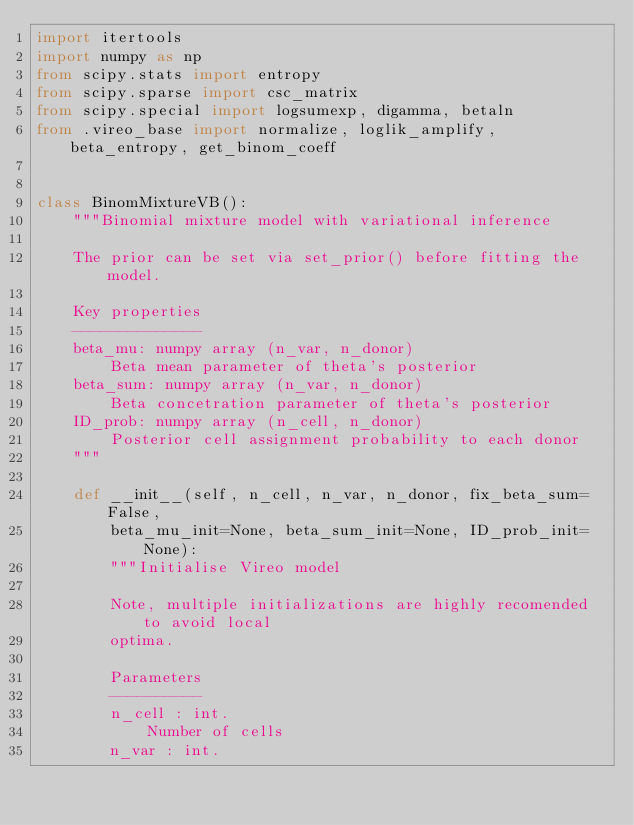Convert code to text. <code><loc_0><loc_0><loc_500><loc_500><_Python_>import itertools
import numpy as np
from scipy.stats import entropy
from scipy.sparse import csc_matrix
from scipy.special import logsumexp, digamma, betaln
from .vireo_base import normalize, loglik_amplify, beta_entropy, get_binom_coeff


class BinomMixtureVB():
    """Binomial mixture model with variational inference

    The prior can be set via set_prior() before fitting the model.

    Key properties
    --------------
    beta_mu: numpy array (n_var, n_donor)
        Beta mean parameter of theta's posterior
    beta_sum: numpy array (n_var, n_donor)
        Beta concetration parameter of theta's posterior
    ID_prob: numpy array (n_cell, n_donor)
        Posterior cell assignment probability to each donor
    """

    def __init__(self, n_cell, n_var, n_donor, fix_beta_sum=False, 
        beta_mu_init=None, beta_sum_init=None, ID_prob_init=None):
        """Initialise Vireo model

        Note, multiple initializations are highly recomended to avoid local 
        optima.
        
        Parameters
        ----------
        n_cell : int. 
            Number of cells
        n_var : int. </code> 